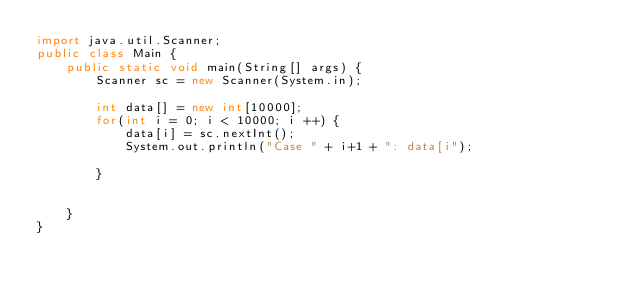<code> <loc_0><loc_0><loc_500><loc_500><_Java_>import java.util.Scanner;
public class Main {
	public static void main(String[] args) {
		Scanner sc = new Scanner(System.in);

		int data[] = new int[10000];
		for(int i = 0; i < 10000; i ++) {
			data[i] = sc.nextInt();
			System.out.println("Case " + i+1 + ": data[i");

		}


	}
}
</code> 